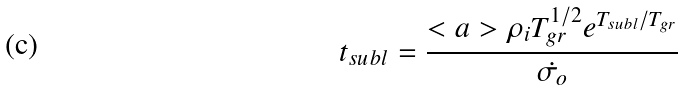Convert formula to latex. <formula><loc_0><loc_0><loc_500><loc_500>t _ { s u b l } = \frac { < a > \rho _ { i } T _ { g r } ^ { 1 / 2 } e ^ { T _ { s u b l } / T _ { g r } } } { \dot { \sigma _ { o } } }</formula> 